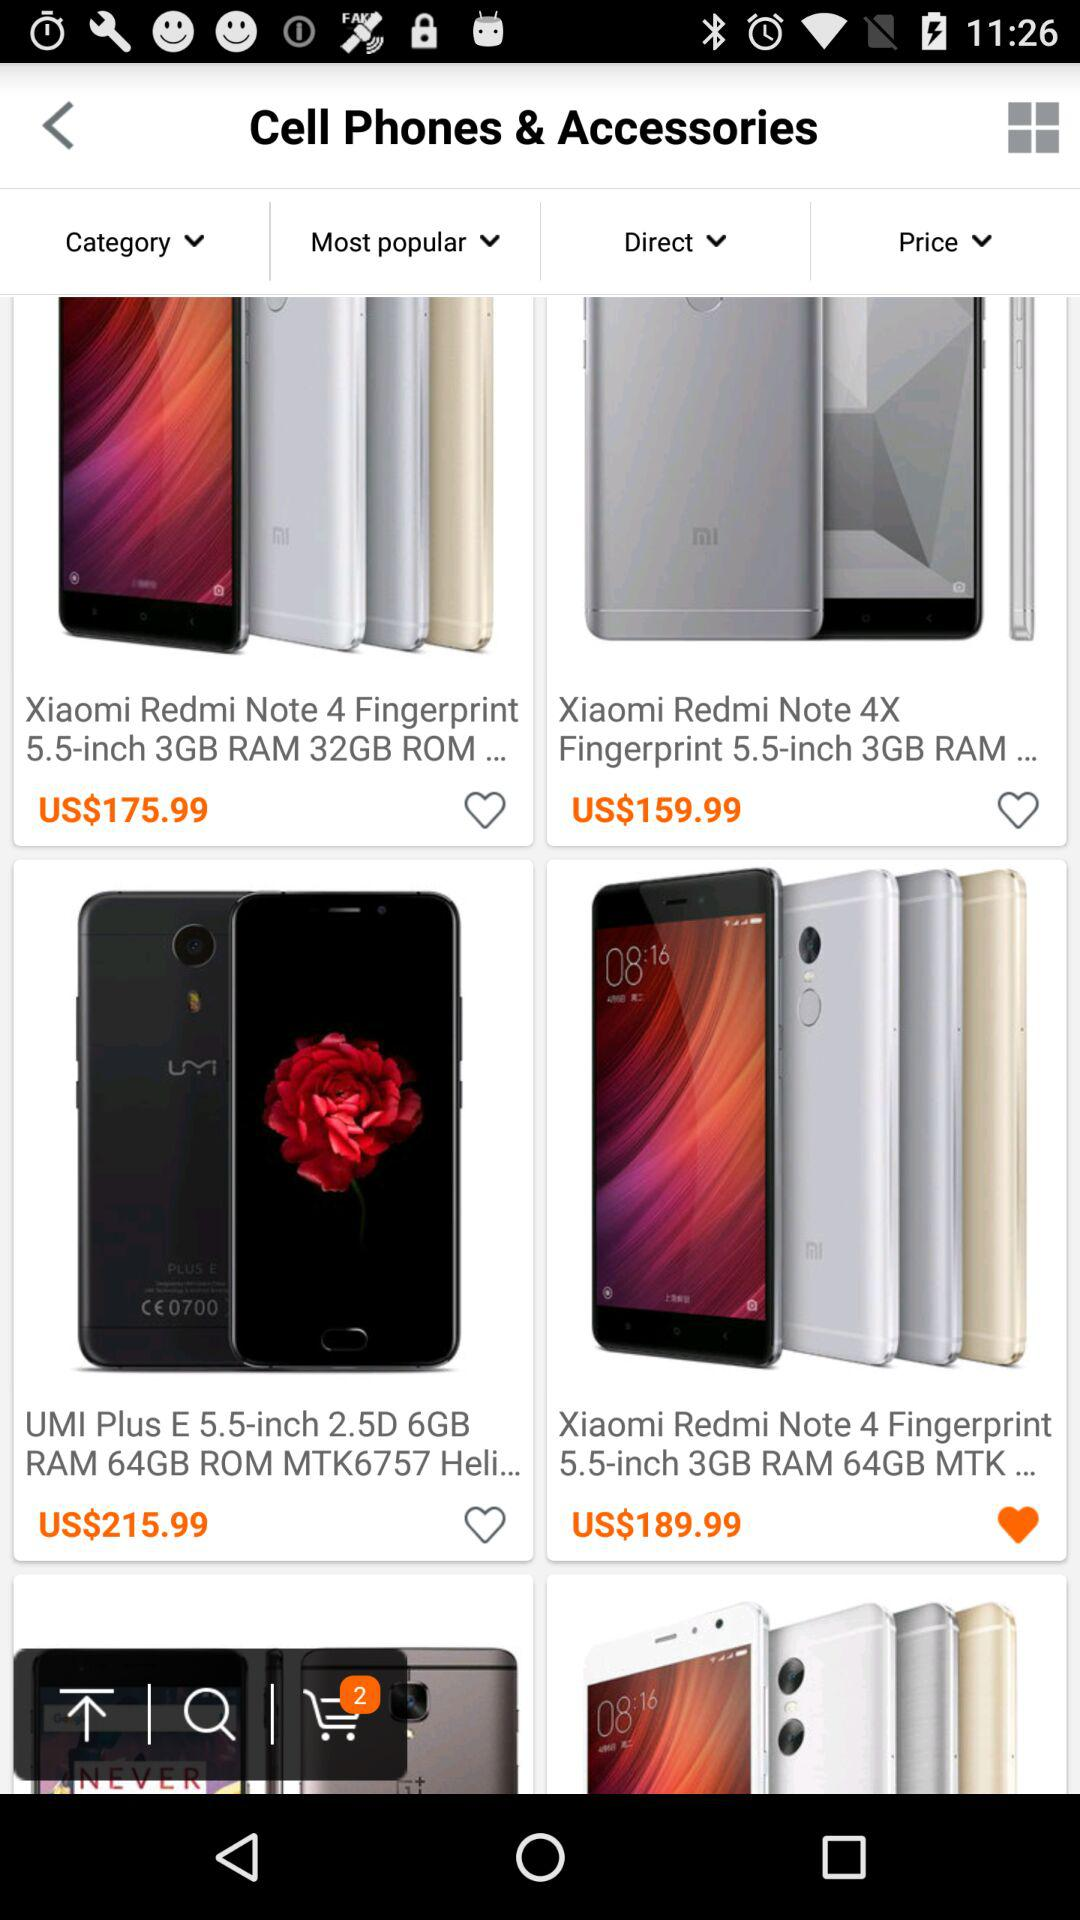How many products have been added to the cart? The number of products that have been added to the cart is 2. 